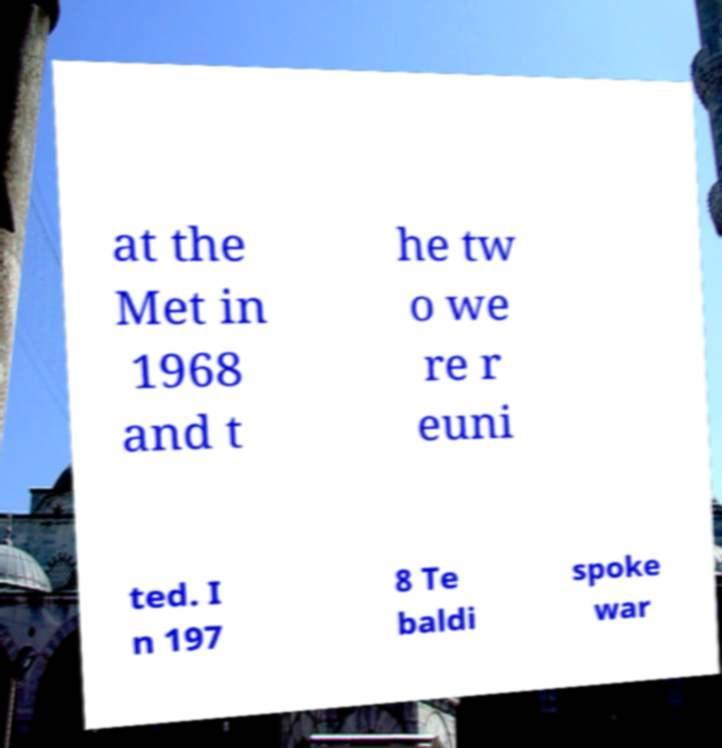Please read and relay the text visible in this image. What does it say? at the Met in 1968 and t he tw o we re r euni ted. I n 197 8 Te baldi spoke war 